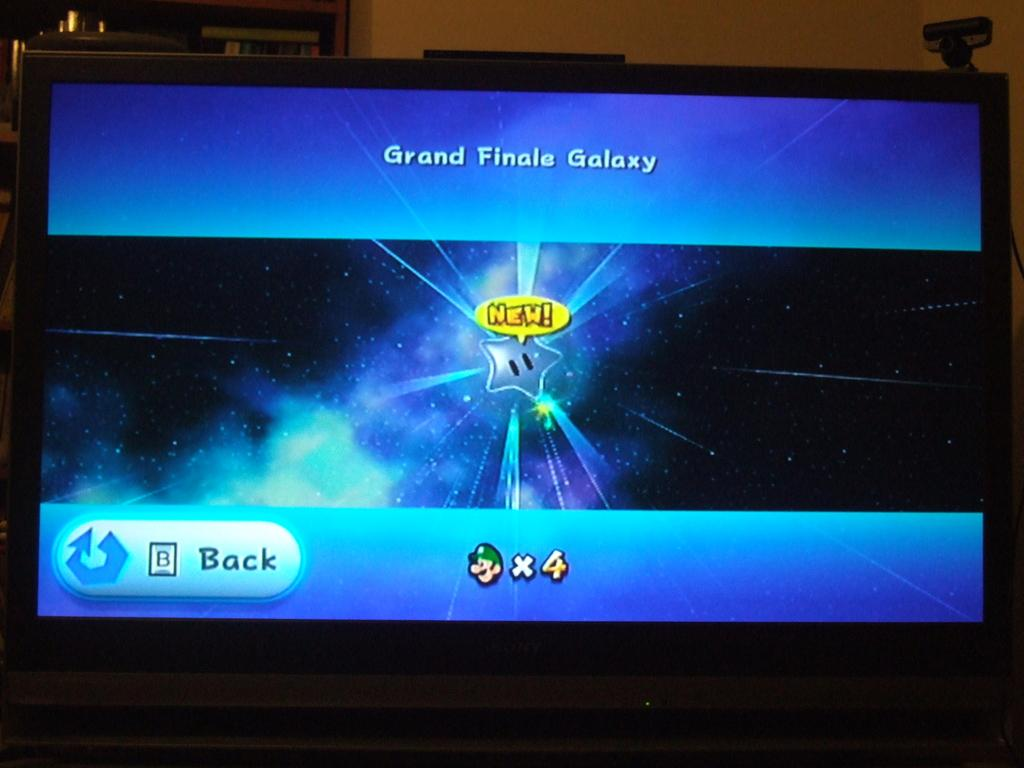<image>
Write a terse but informative summary of the picture. A game screen depicts the grand finale galaxy on a TV screen. 